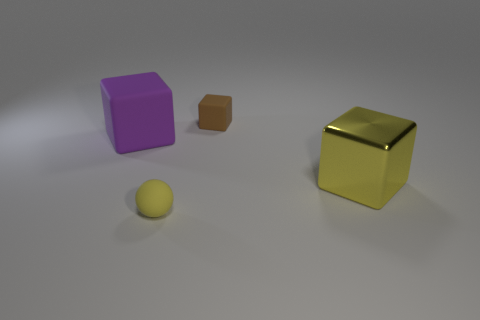There is a yellow sphere that is to the left of the cube that is behind the object that is left of the rubber sphere; what is its size?
Ensure brevity in your answer.  Small. Are any big yellow matte blocks visible?
Ensure brevity in your answer.  No. What is the material of the small thing that is the same color as the large metal thing?
Keep it short and to the point. Rubber. What number of tiny spheres are the same color as the metallic object?
Your answer should be very brief. 1. How many things are either yellow things that are left of the big yellow metallic object or rubber objects that are behind the big yellow cube?
Keep it short and to the point. 3. What number of things are behind the cube that is in front of the big purple cube?
Offer a terse response. 2. There is a large thing that is the same material as the small yellow object; what is its color?
Your answer should be compact. Purple. Are there any blue cylinders of the same size as the brown matte object?
Keep it short and to the point. No. There is a metal thing that is the same size as the purple matte cube; what shape is it?
Offer a very short reply. Cube. Are there any yellow things of the same shape as the brown object?
Your response must be concise. Yes. 